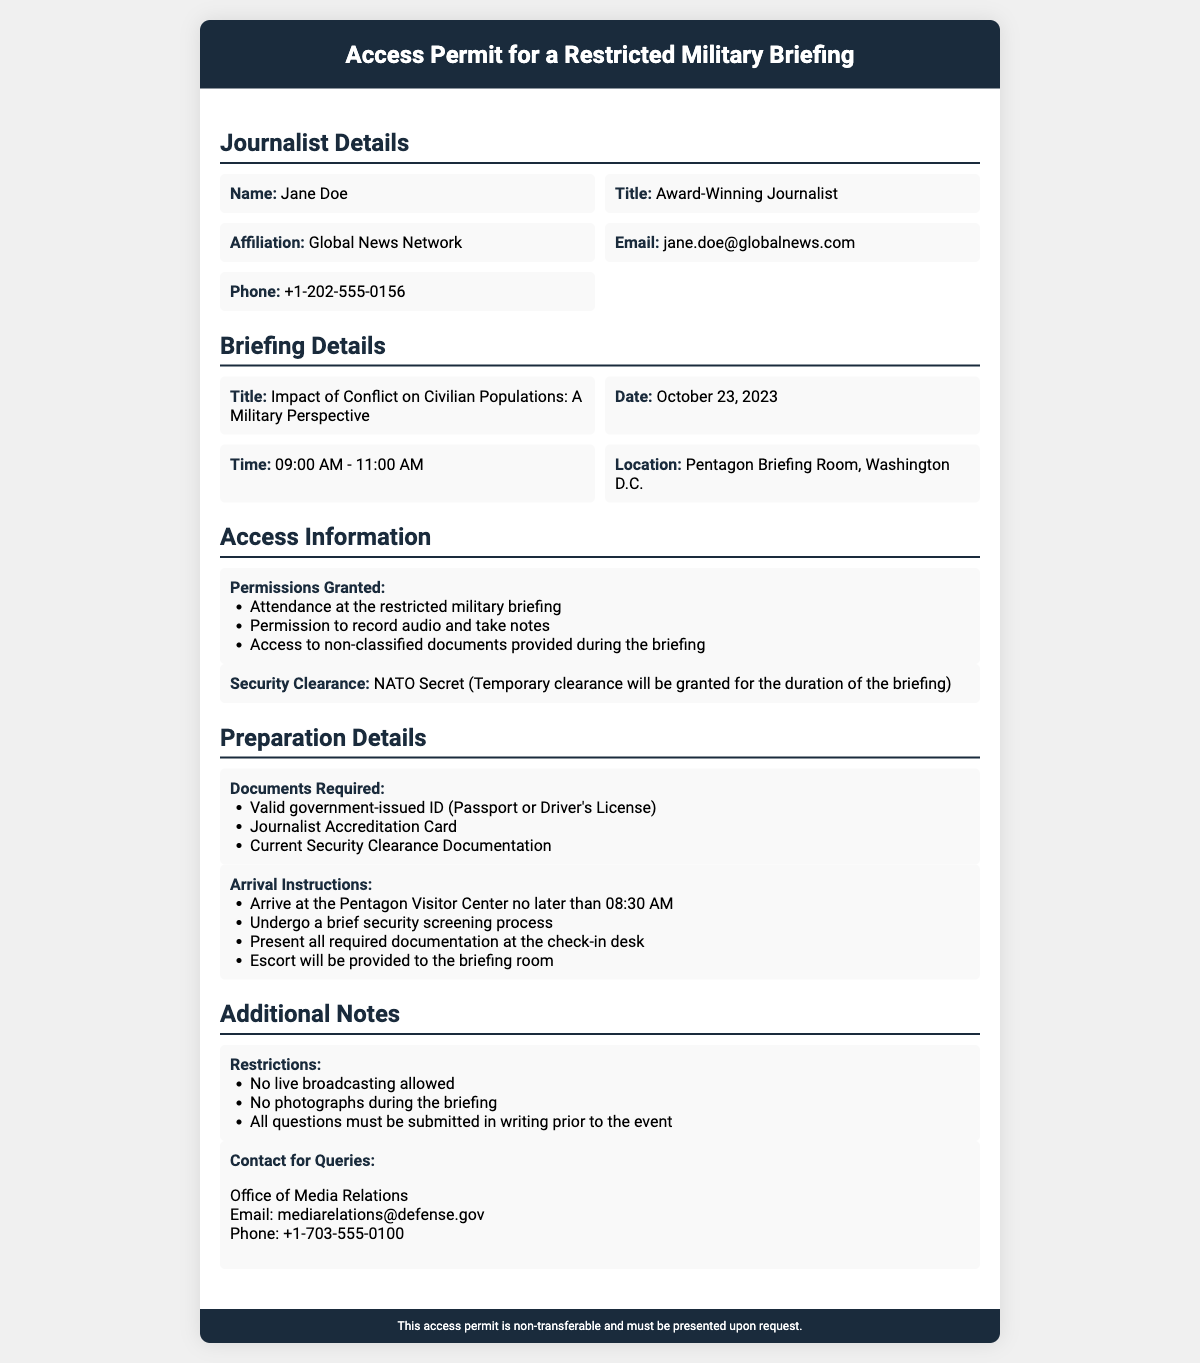What is the name of the journalist? The name of the journalist is stated in the document under "Journalist Details".
Answer: Jane Doe What is the title of the briefing? The title of the briefing is clearly indicated in the "Briefing Details" section of the document.
Answer: Impact of Conflict on Civilian Populations: A Military Perspective What is the date of the briefing? The date of the briefing is provided in the "Briefing Details" section.
Answer: October 23, 2023 What security clearance is required? The required security clearance is mentioned in the "Access Information" section of the document.
Answer: NATO Secret What time should the journalist arrive at the Pentagon? The arrival instructions specify the required time in the "Preparation Details" section.
Answer: 08:30 AM What document must be presented along with the ID? The "Documents Required" section lists this information, specifically mentioning the type of accreditation.
Answer: Journalist Accreditation Card What are journalists prohibited from doing during the briefing? The "Additional Notes" section outlines specific restrictions for the briefing.
Answer: No live broadcasting allowed Who should queries be directed to? The contact information for queries is given in the "Additional Notes" section.
Answer: Office of Media Relations What is the phone number for the Office of Media Relations? The phone number is provided under the contact information in the "Additional Notes" section.
Answer: +1-703-555-0100 